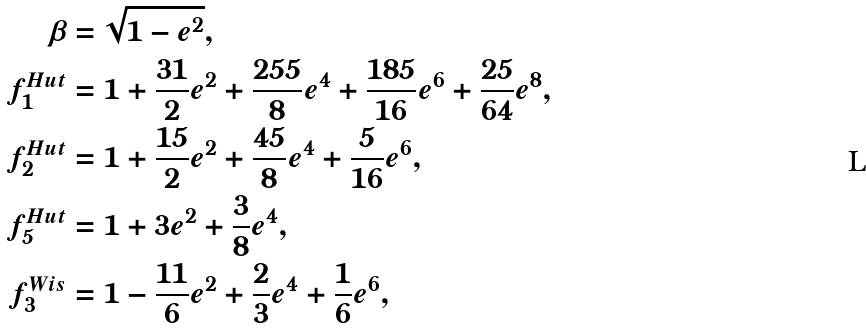Convert formula to latex. <formula><loc_0><loc_0><loc_500><loc_500>\beta & = \sqrt { 1 - e ^ { 2 } } , \\ f _ { 1 } ^ { H u t } & = 1 + \frac { 3 1 } { 2 } e ^ { 2 } + \frac { 2 5 5 } { 8 } e ^ { 4 } + \frac { 1 8 5 } { 1 6 } e ^ { 6 } + \frac { 2 5 } { 6 4 } e ^ { 8 } , \\ f _ { 2 } ^ { H u t } & = 1 + \frac { 1 5 } { 2 } e ^ { 2 } + \frac { 4 5 } { 8 } e ^ { 4 } + \frac { 5 } { 1 6 } e ^ { 6 } , \\ f _ { 5 } ^ { H u t } & = 1 + 3 e ^ { 2 } + \frac { 3 } { 8 } e ^ { 4 } , \\ f _ { 3 } ^ { W i s } & = 1 - \frac { 1 1 } { 6 } e ^ { 2 } + \frac { 2 } { 3 } e ^ { 4 } + \frac { 1 } { 6 } e ^ { 6 } , \\</formula> 